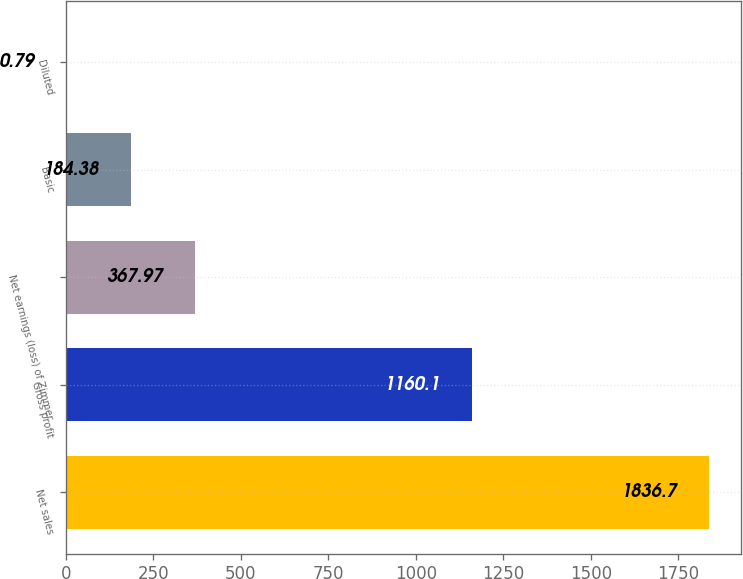Convert chart to OTSL. <chart><loc_0><loc_0><loc_500><loc_500><bar_chart><fcel>Net sales<fcel>Gross profit<fcel>Net earnings (loss) of Zimmer<fcel>Basic<fcel>Diluted<nl><fcel>1836.7<fcel>1160.1<fcel>367.97<fcel>184.38<fcel>0.79<nl></chart> 